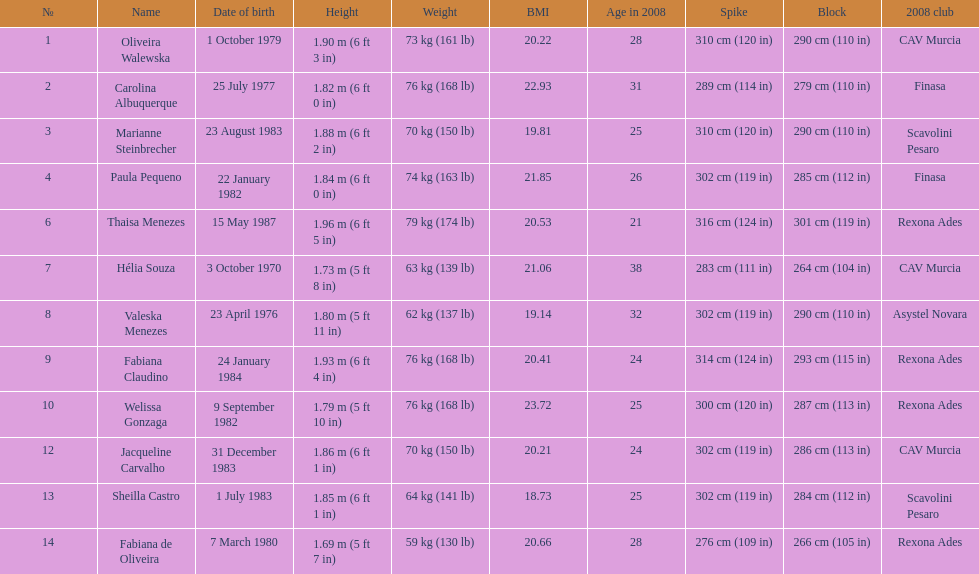Who is the next tallest player after thaisa menezes? Fabiana Claudino. 